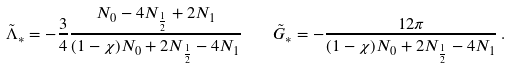Convert formula to latex. <formula><loc_0><loc_0><loc_500><loc_500>\tilde { \Lambda } _ { * } = - \frac { 3 } { 4 } \frac { N _ { 0 } - 4 N _ { \frac { 1 } { 2 } } + 2 N _ { 1 } } { ( 1 - \chi ) N _ { 0 } + 2 N _ { \frac { 1 } { 2 } } - 4 N _ { 1 } } \quad \tilde { G } _ { * } = - \frac { 1 2 \pi } { ( 1 - \chi ) N _ { 0 } + 2 N _ { \frac { 1 } { 2 } } - 4 N _ { 1 } } \, .</formula> 